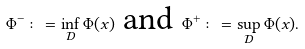<formula> <loc_0><loc_0><loc_500><loc_500>\Phi ^ { - } \colon = \inf _ { \mathcal { D } } \Phi ( x ) \text { and } \Phi ^ { + } \colon = \sup _ { \mathcal { D } } \Phi ( x ) .</formula> 